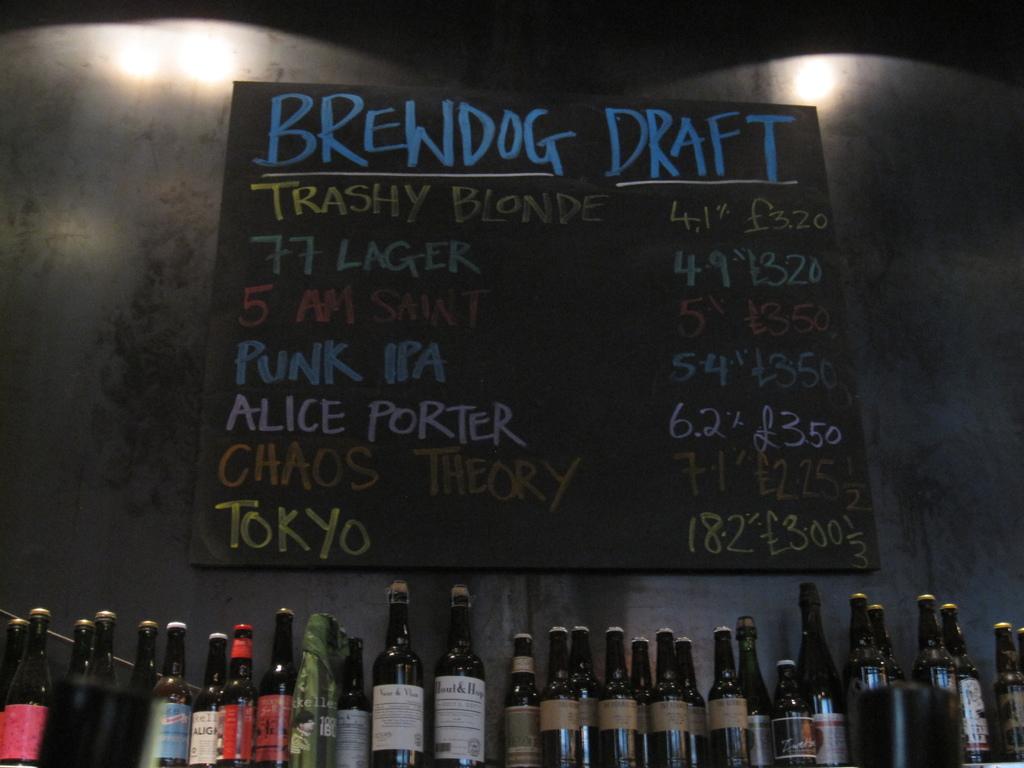What draft is the most expensive?
Offer a terse response. Punk ipa. What is the brewer name?
Keep it short and to the point. Brewdog. 